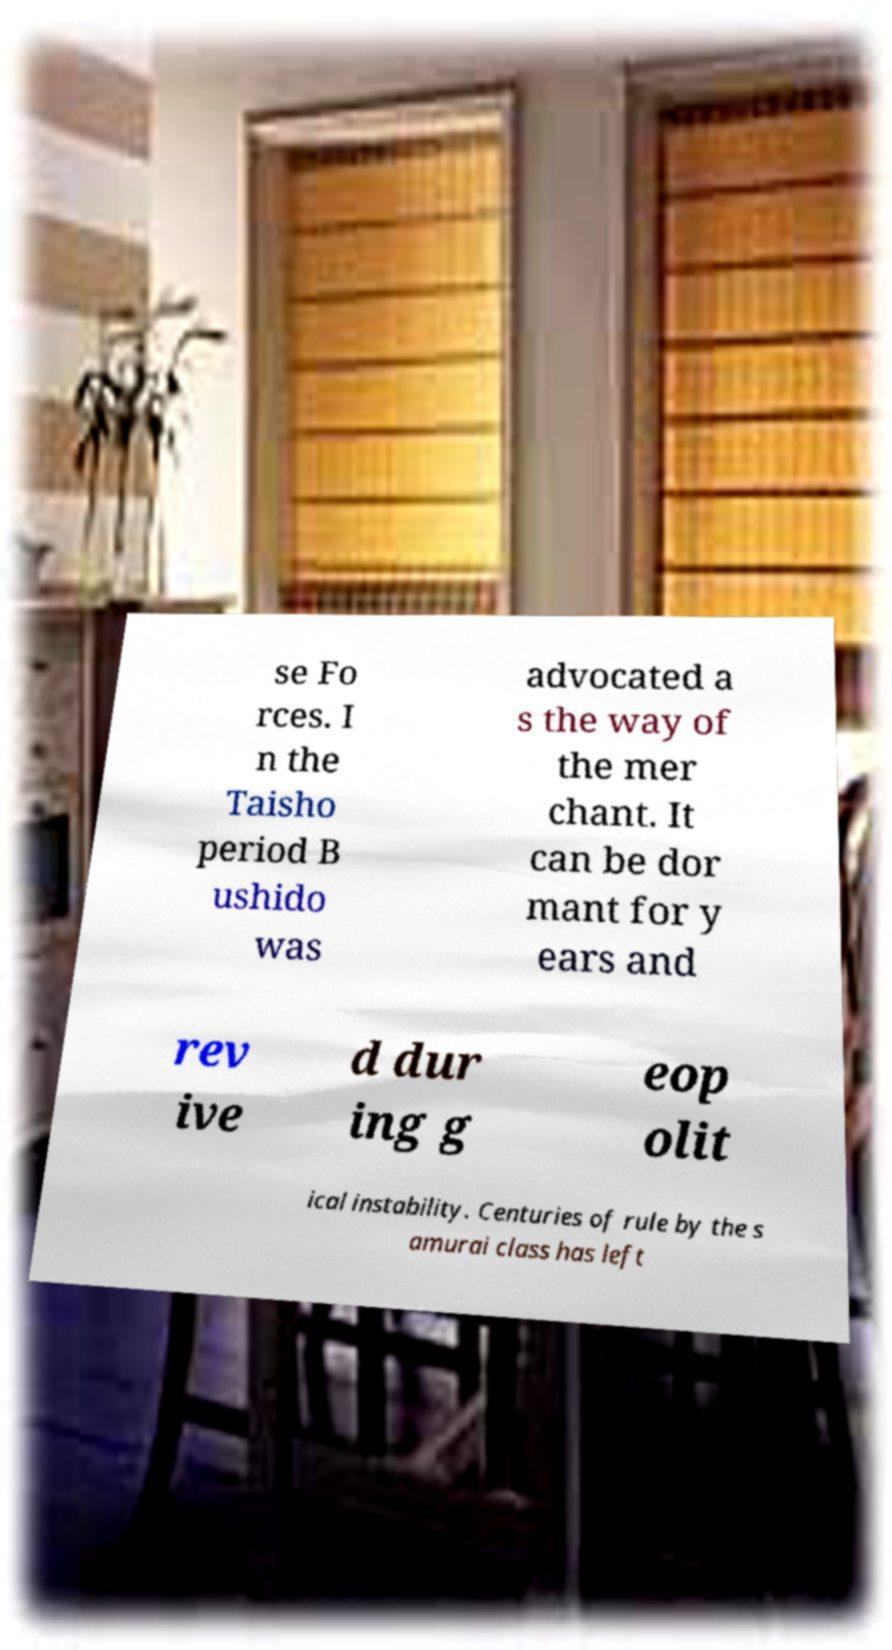I need the written content from this picture converted into text. Can you do that? se Fo rces. I n the Taisho period B ushido was advocated a s the way of the mer chant. It can be dor mant for y ears and rev ive d dur ing g eop olit ical instability. Centuries of rule by the s amurai class has left 